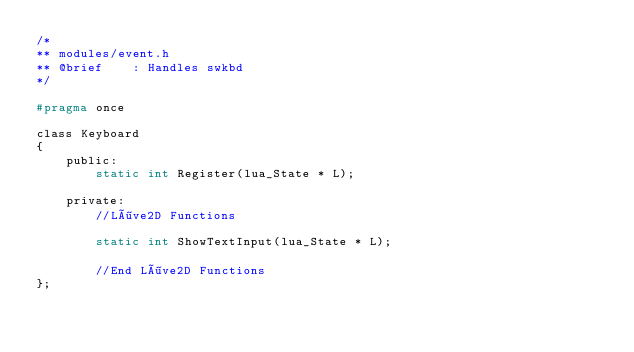<code> <loc_0><loc_0><loc_500><loc_500><_C_>/*
** modules/event.h
** @brief    : Handles swkbd
*/

#pragma once

class Keyboard
{
    public:
        static int Register(lua_State * L);
    
    private:
        //Löve2D Functions
        
        static int ShowTextInput(lua_State * L);

        //End Löve2D Functions
};
</code> 